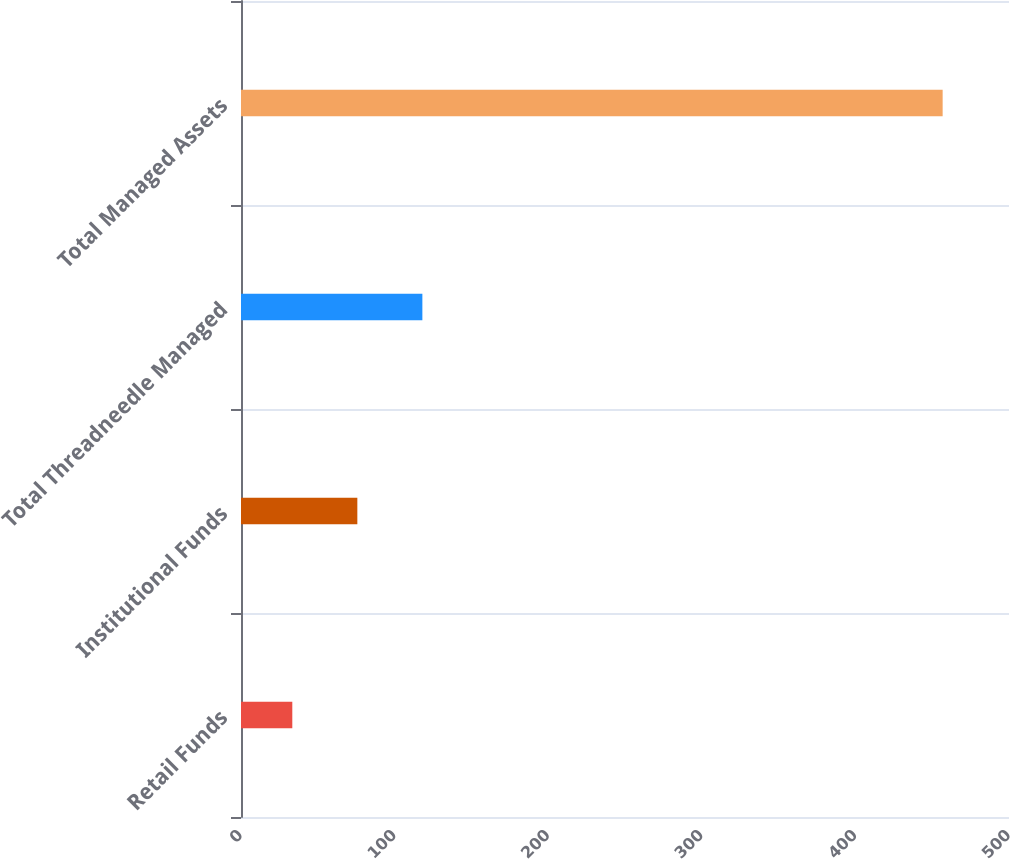Convert chart. <chart><loc_0><loc_0><loc_500><loc_500><bar_chart><fcel>Retail Funds<fcel>Institutional Funds<fcel>Total Threadneedle Managed<fcel>Total Managed Assets<nl><fcel>33.4<fcel>75.74<fcel>118.08<fcel>456.8<nl></chart> 